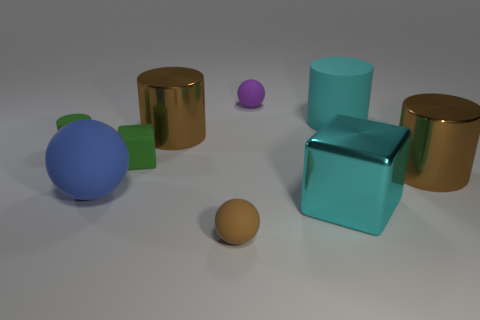Does the big ball have the same color as the big matte cylinder?
Keep it short and to the point. No. There is a large cyan cylinder behind the big brown cylinder on the right side of the tiny ball that is in front of the cyan cube; what is it made of?
Your answer should be compact. Rubber. There is a small purple matte sphere; are there any small brown things behind it?
Provide a succinct answer. No. There is a purple matte object that is the same size as the brown rubber object; what is its shape?
Make the answer very short. Sphere. Are the large block and the small cylinder made of the same material?
Make the answer very short. No. What number of matte things are either green cubes or small purple balls?
Make the answer very short. 2. There is a shiny object that is the same color as the large rubber cylinder; what shape is it?
Provide a short and direct response. Cube. Does the thing behind the large rubber cylinder have the same color as the tiny block?
Give a very brief answer. No. What shape is the big rubber thing that is behind the tiny green thing on the left side of the big rubber sphere?
Offer a very short reply. Cylinder. How many objects are either big cylinders right of the cyan metallic block or brown things that are in front of the green cylinder?
Give a very brief answer. 3. 